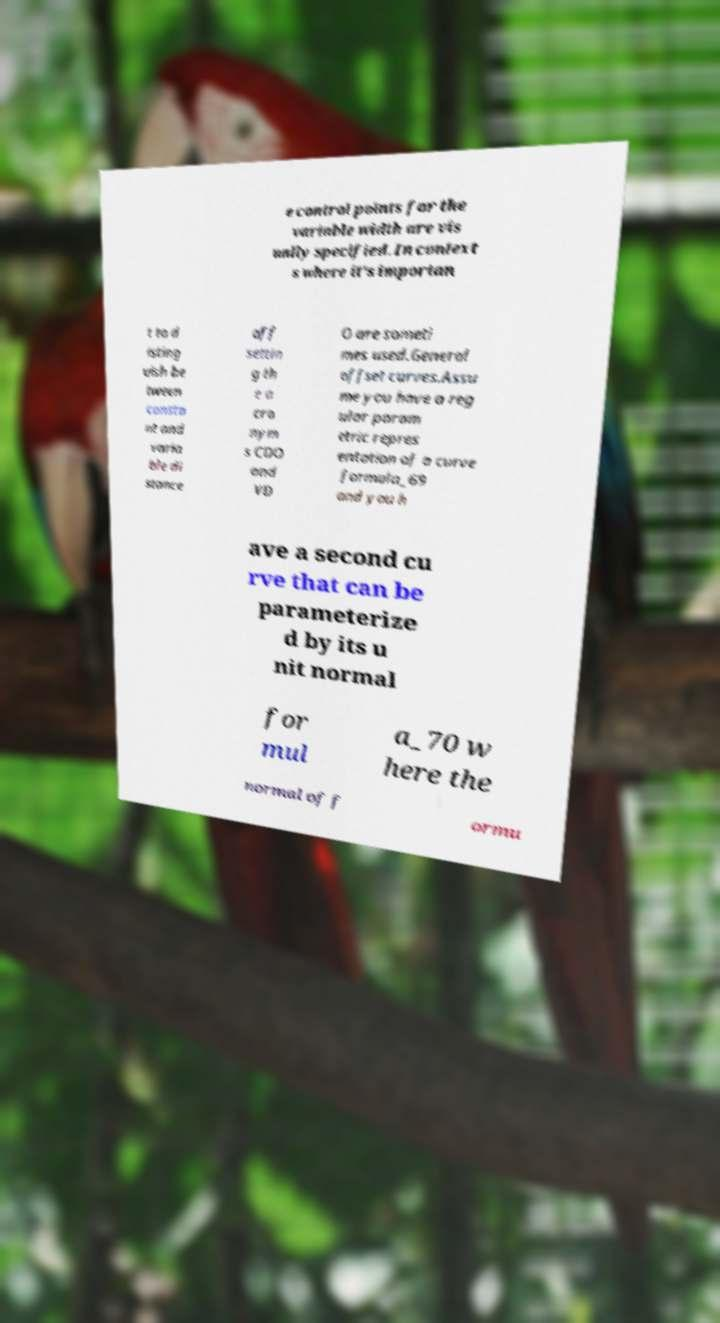Could you assist in decoding the text presented in this image and type it out clearly? e control points for the variable width are vis ually specified. In context s where it's importan t to d isting uish be tween consta nt and varia ble di stance off settin g th e a cro nym s CDO and VD O are someti mes used.General offset curves.Assu me you have a reg ular param etric repres entation of a curve formula_69 and you h ave a second cu rve that can be parameterize d by its u nit normal for mul a_70 w here the normal of f ormu 